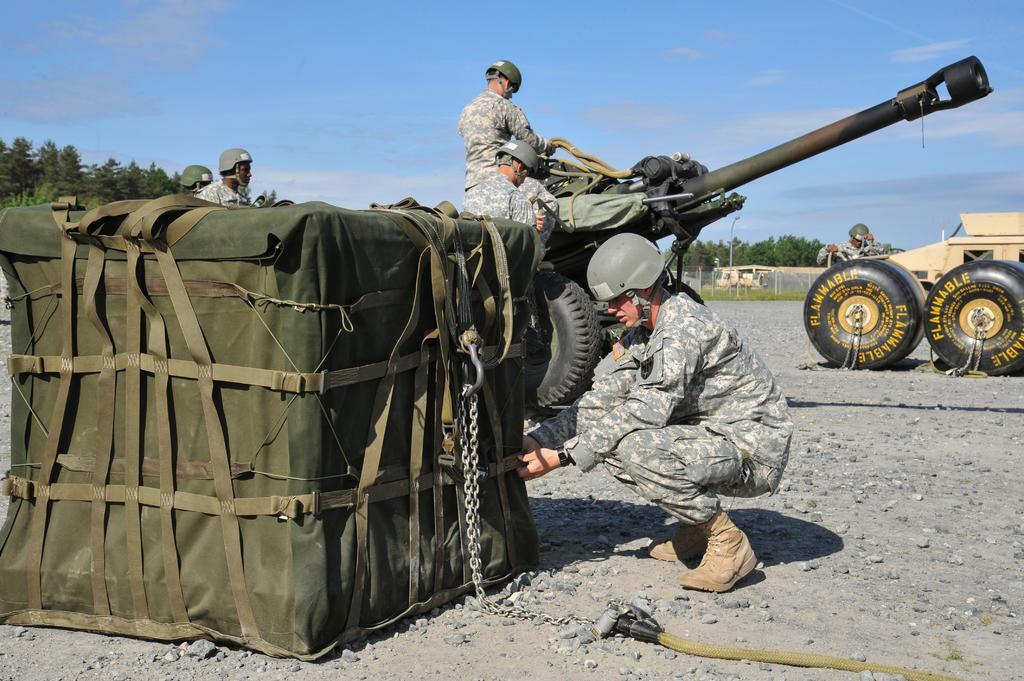Can you describe this image briefly? In this image there is one object kept on the left side of this image and there is one person sitting at right side to this object. There is one vehicle at right side of this image and there is one another vehicle in middle of this image. There are two persons standing on to this vehicle and there are some persons at left side of this image ,and there are some trees in the background. There is a sky at top of this image. There is one pipe on the bottom of this image. 